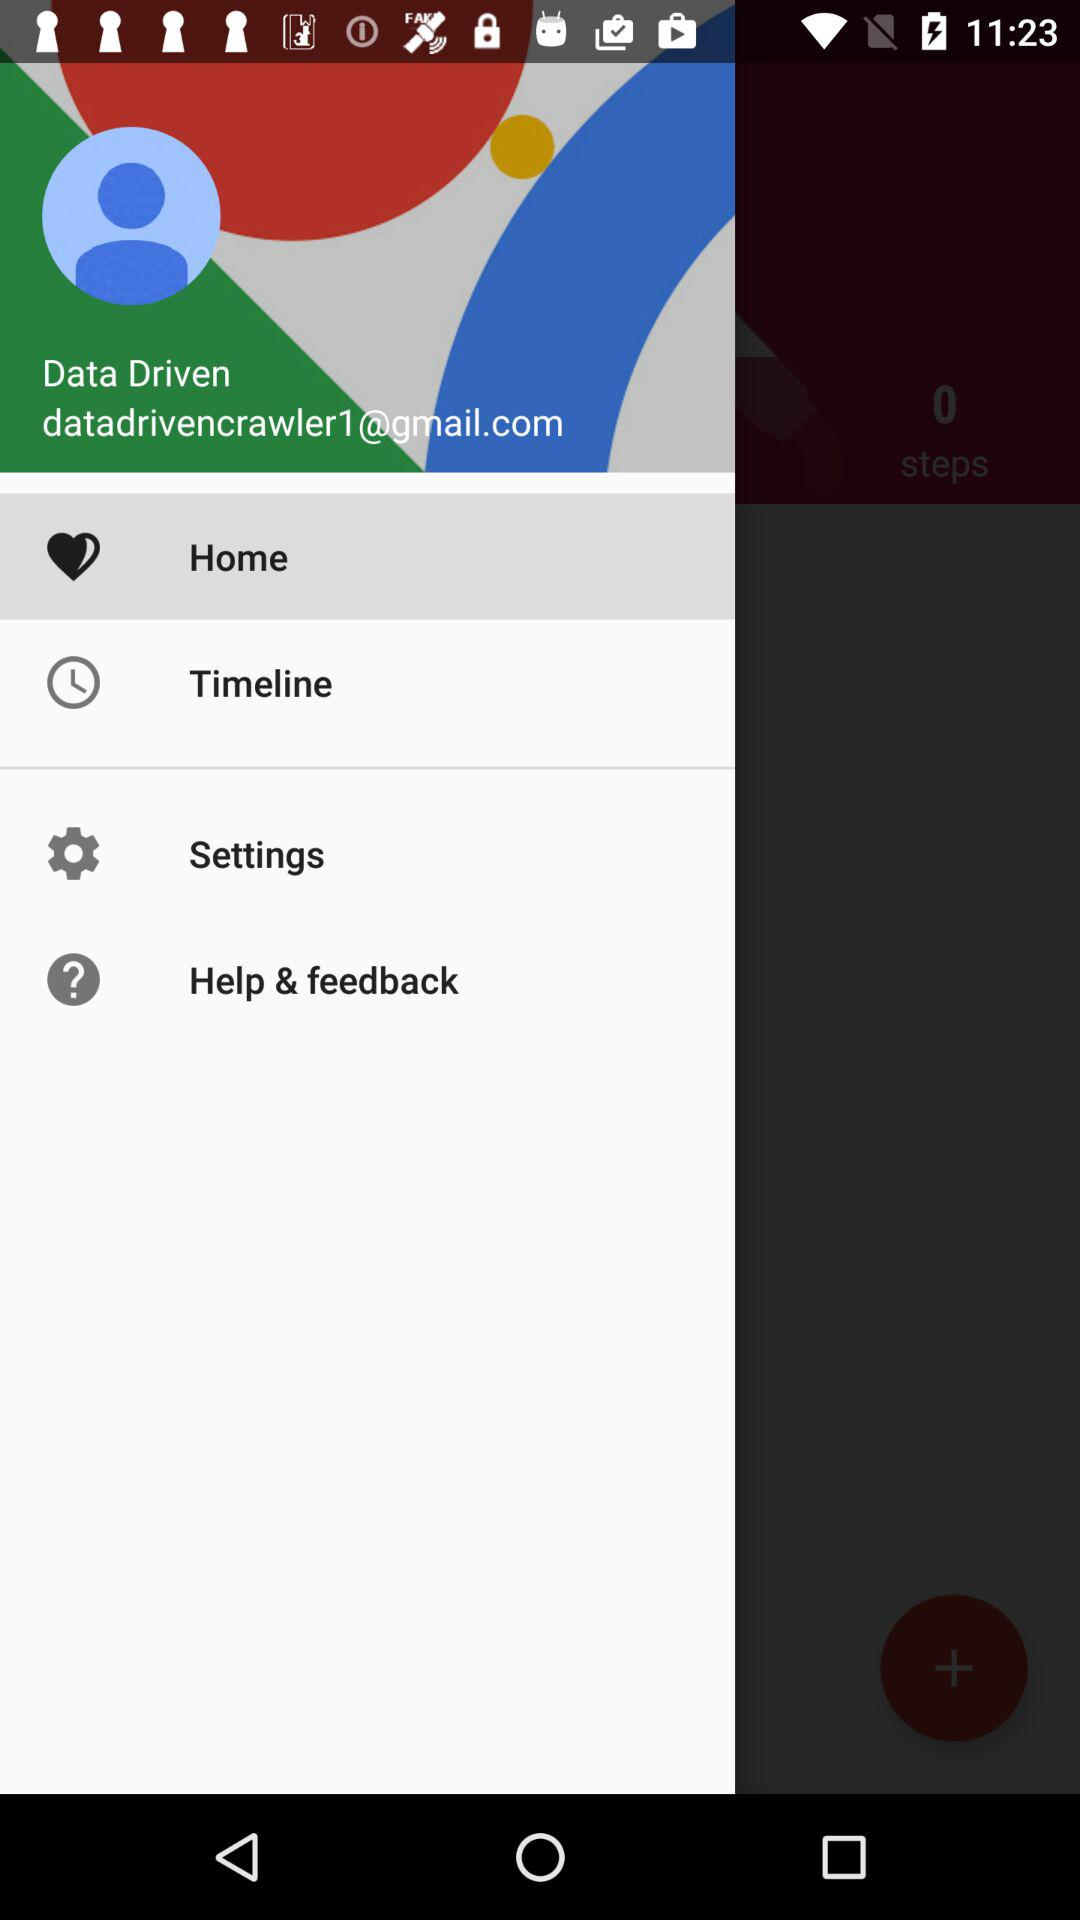What is the email address? The email address is datadrivencrawler1@gmail.com. 